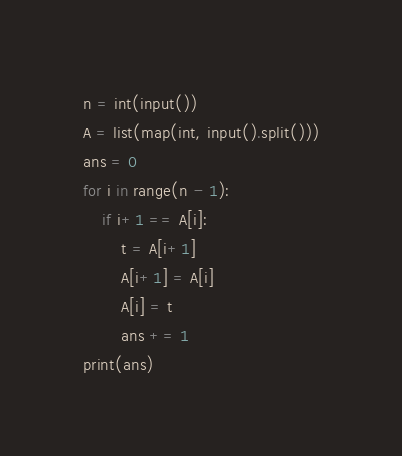Convert code to text. <code><loc_0><loc_0><loc_500><loc_500><_Python_>n = int(input())
A = list(map(int, input().split()))
ans = 0
for i in range(n - 1):
    if i+1 == A[i]:
        t = A[i+1]
        A[i+1] = A[i]
        A[i] = t
        ans += 1
print(ans)</code> 